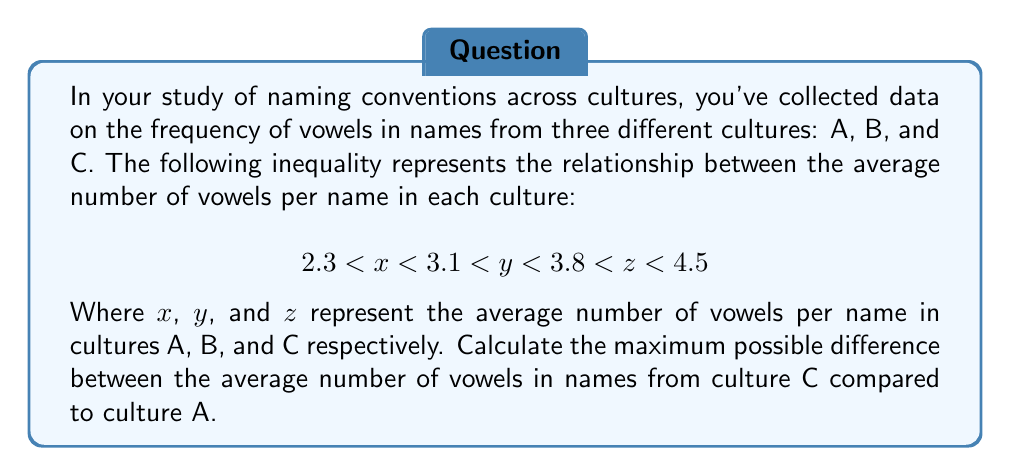Show me your answer to this math problem. To find the maximum possible difference between the average number of vowels in names from culture C compared to culture A, we need to:

1. Identify the maximum possible value for culture C (z):
   $z < 4.5$, so the maximum value for z is just under 4.5.

2. Identify the minimum possible value for culture A (x):
   $2.3 < x$, so the minimum value for x is just over 2.3.

3. Calculate the difference between these values:

   $$ \text{Maximum difference} = \text{Maximum z} - \text{Minimum x} $$
   $$ \text{Maximum difference} \approx 4.5 - 2.3 = 2.2 $$

The approximation symbol is used because the actual maximum value for z is slightly less than 4.5, and the actual minimum value for x is slightly more than 2.3. However, this gives us the largest possible difference between the two cultures' average vowel counts.
Answer: 2.2 